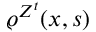<formula> <loc_0><loc_0><loc_500><loc_500>\varrho ^ { Z ^ { t } } ( x , s )</formula> 